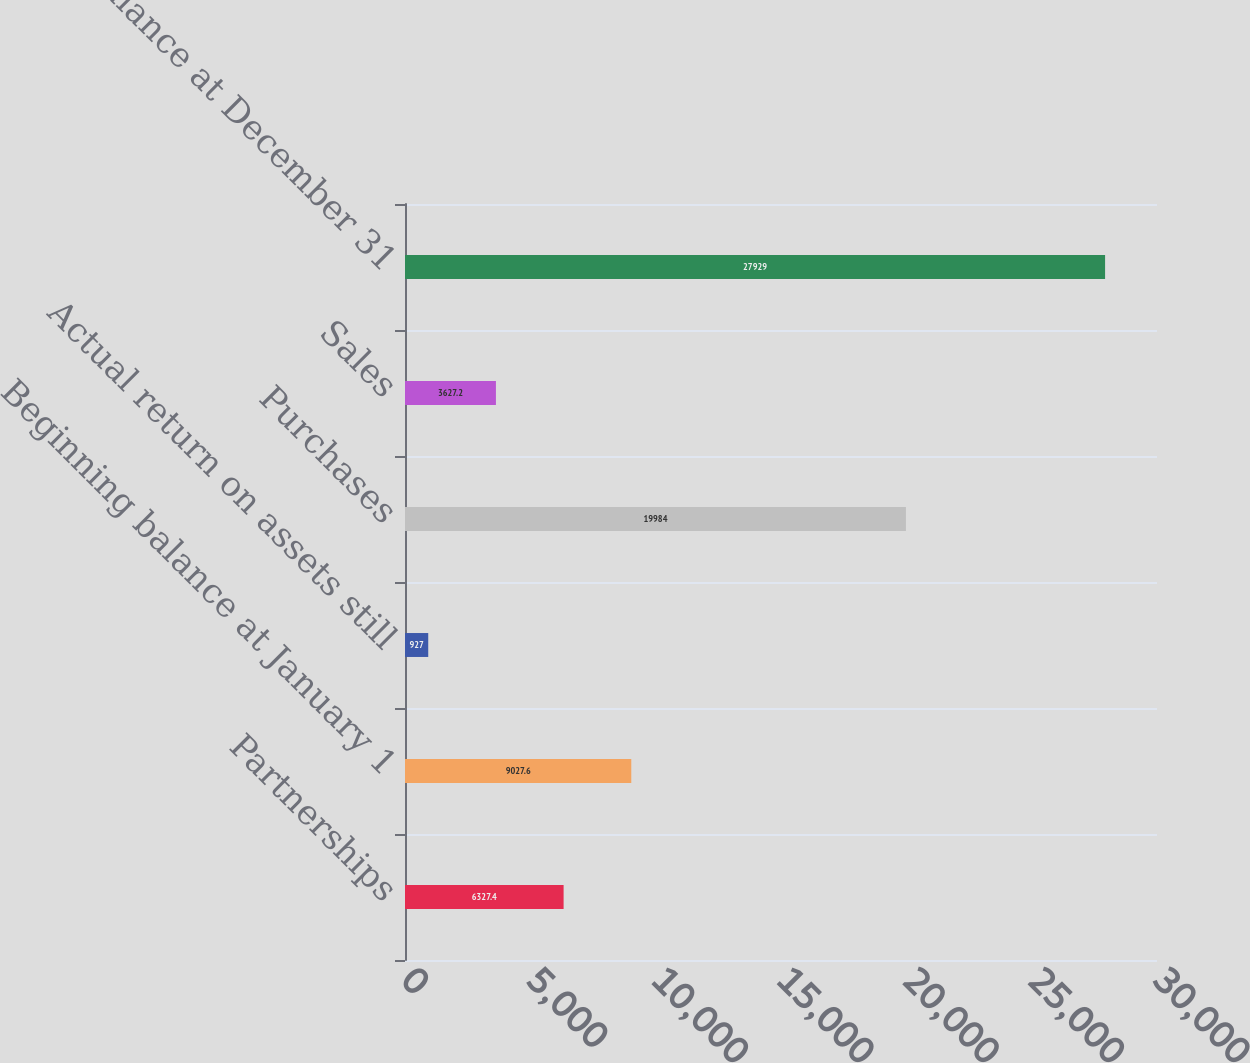Convert chart. <chart><loc_0><loc_0><loc_500><loc_500><bar_chart><fcel>Partnerships<fcel>Beginning balance at January 1<fcel>Actual return on assets still<fcel>Purchases<fcel>Sales<fcel>Ending balance at December 31<nl><fcel>6327.4<fcel>9027.6<fcel>927<fcel>19984<fcel>3627.2<fcel>27929<nl></chart> 